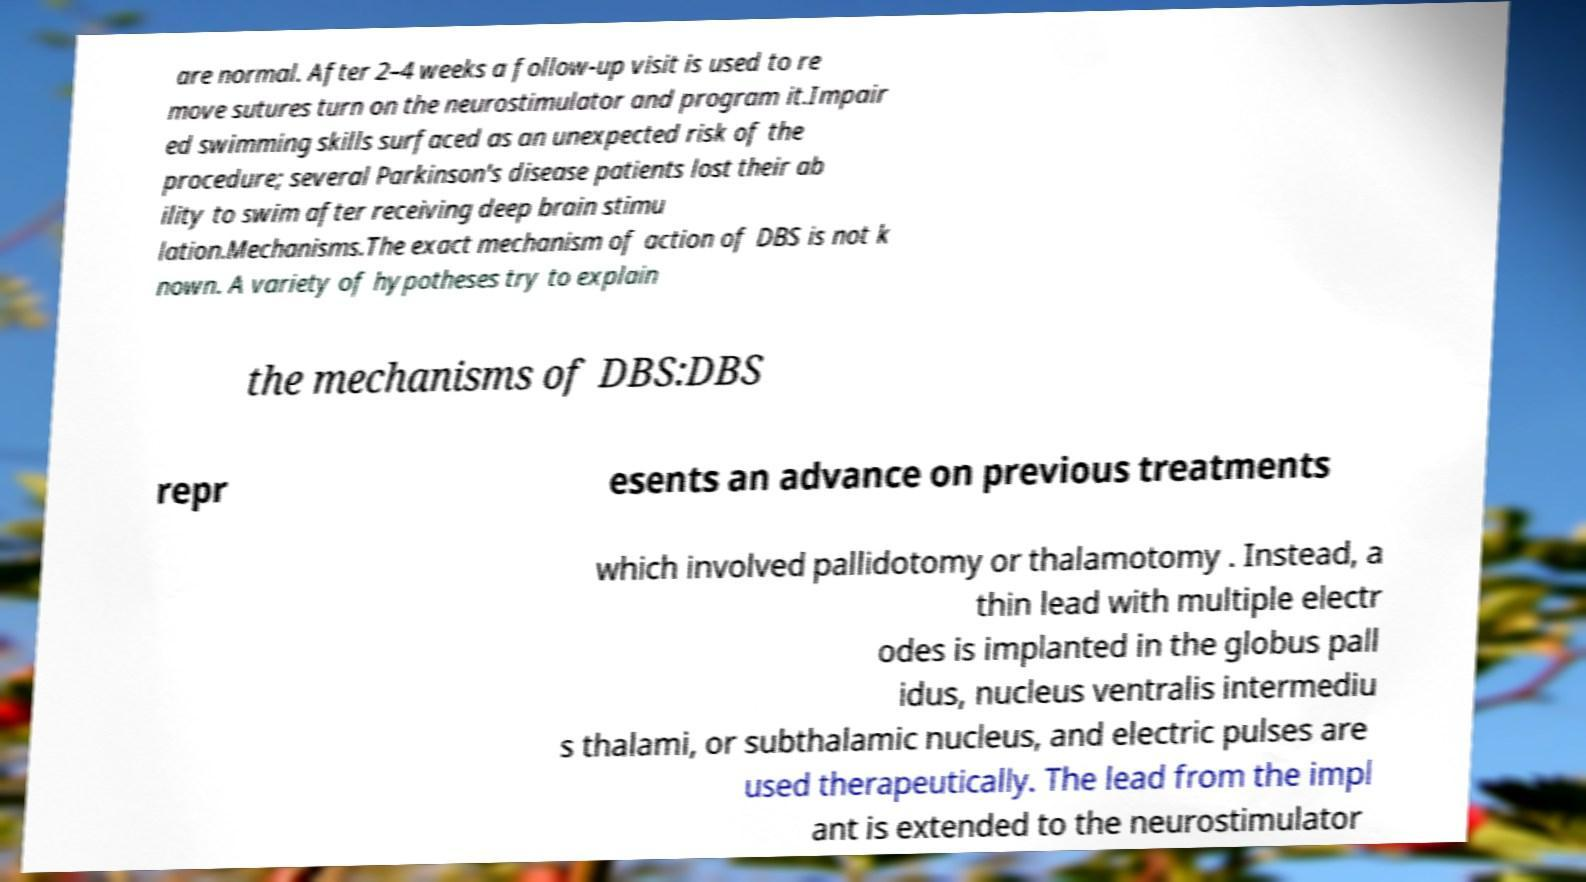Could you assist in decoding the text presented in this image and type it out clearly? are normal. After 2–4 weeks a follow-up visit is used to re move sutures turn on the neurostimulator and program it.Impair ed swimming skills surfaced as an unexpected risk of the procedure; several Parkinson's disease patients lost their ab ility to swim after receiving deep brain stimu lation.Mechanisms.The exact mechanism of action of DBS is not k nown. A variety of hypotheses try to explain the mechanisms of DBS:DBS repr esents an advance on previous treatments which involved pallidotomy or thalamotomy . Instead, a thin lead with multiple electr odes is implanted in the globus pall idus, nucleus ventralis intermediu s thalami, or subthalamic nucleus, and electric pulses are used therapeutically. The lead from the impl ant is extended to the neurostimulator 